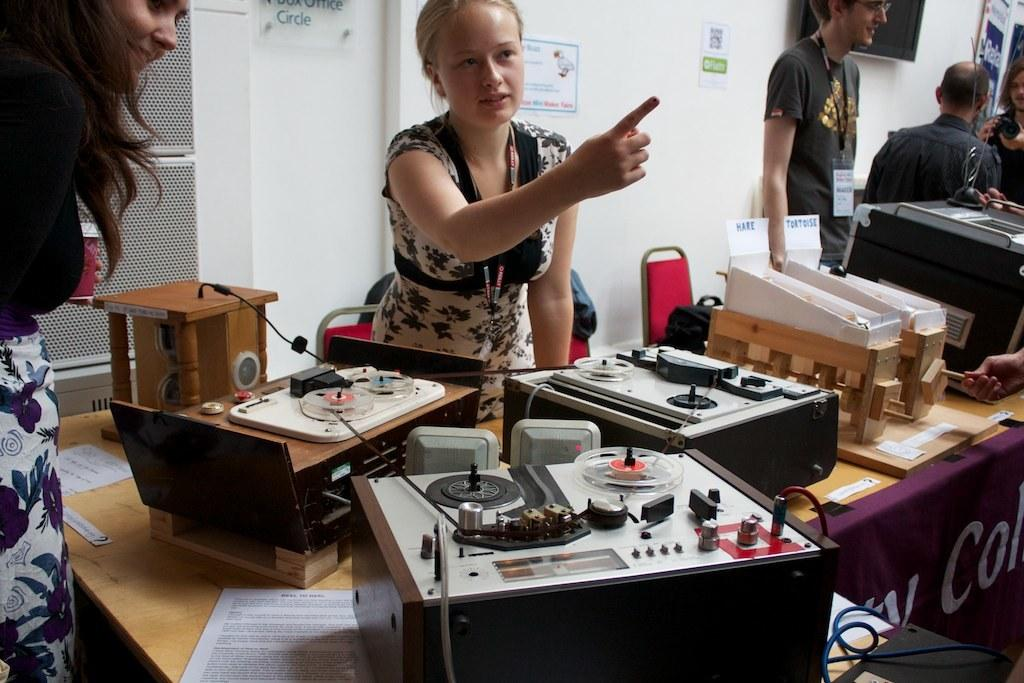What are the people in the image doing? The persons standing on the floor are likely engaging in some activity or conversation. What is the primary piece of furniture in the image? There is a table in the image. What can be found on the table? There are electronic devices on the table. What is visible in the background of the image? There is a wall in the background of the image. What architectural feature is present in the image? There is a door in the image. What type of watch can be seen on the shelf in the image? There is no watch or shelf present in the image. How many ships are visible in the image? There are no ships visible in the image. 